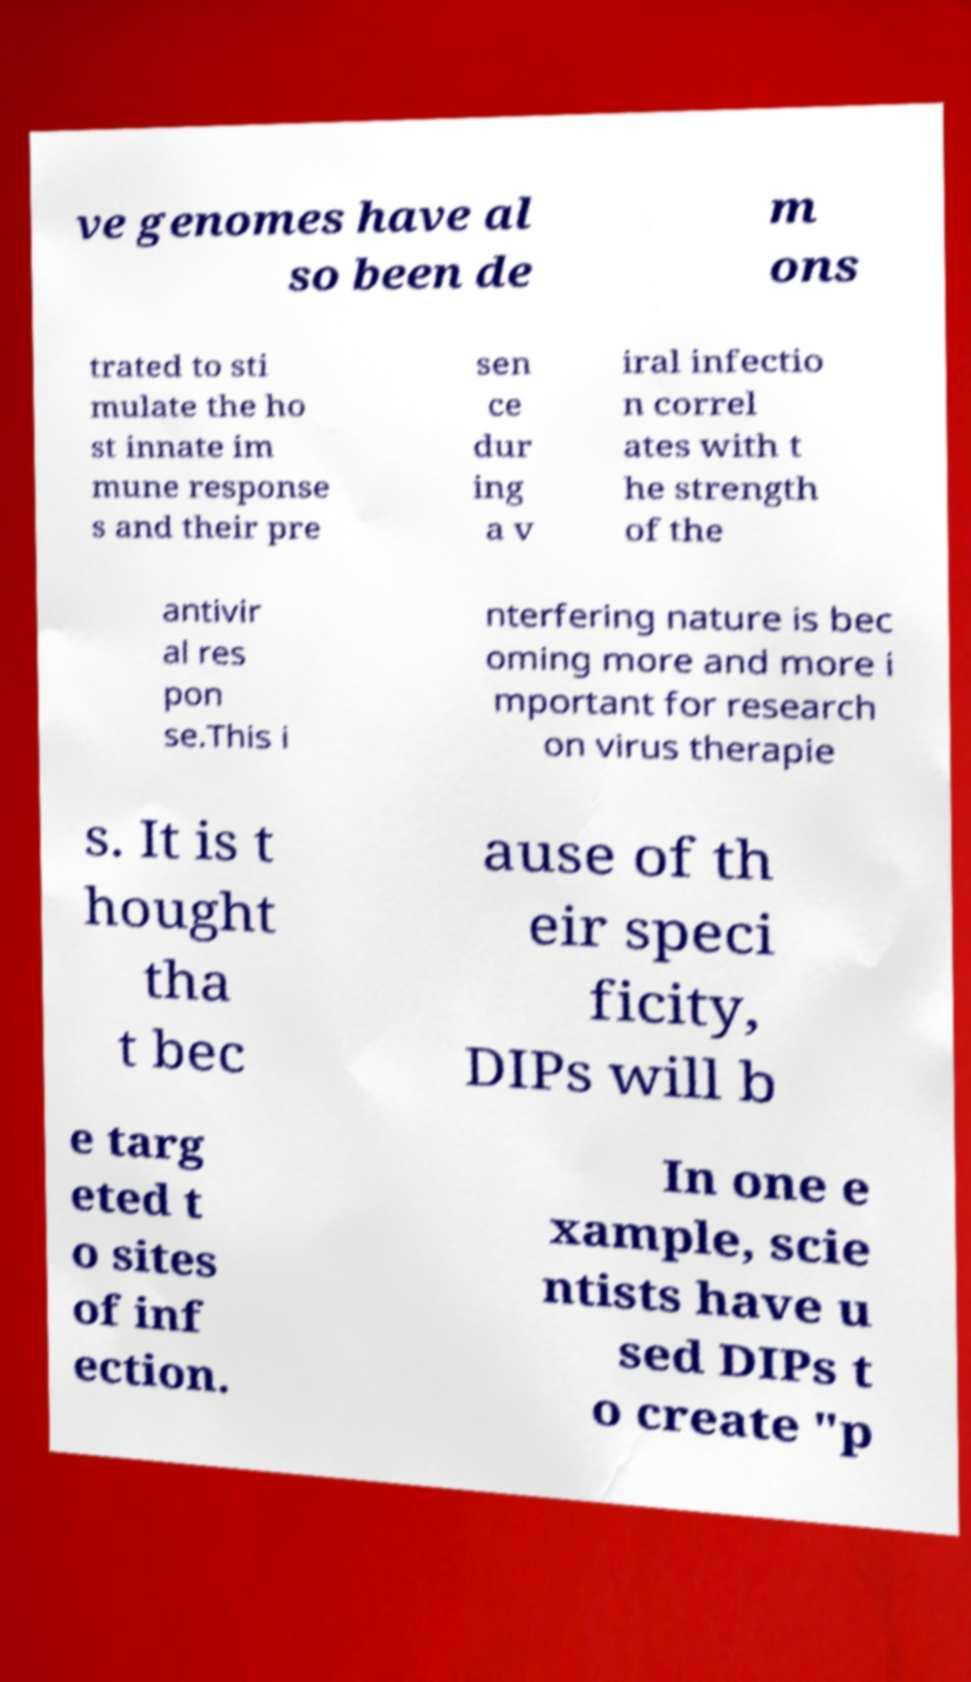For documentation purposes, I need the text within this image transcribed. Could you provide that? ve genomes have al so been de m ons trated to sti mulate the ho st innate im mune response s and their pre sen ce dur ing a v iral infectio n correl ates with t he strength of the antivir al res pon se.This i nterfering nature is bec oming more and more i mportant for research on virus therapie s. It is t hought tha t bec ause of th eir speci ficity, DIPs will b e targ eted t o sites of inf ection. In one e xample, scie ntists have u sed DIPs t o create "p 